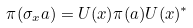<formula> <loc_0><loc_0><loc_500><loc_500>\pi ( \sigma _ { x } a ) = U ( x ) \pi ( a ) U ( x ) ^ { * }</formula> 